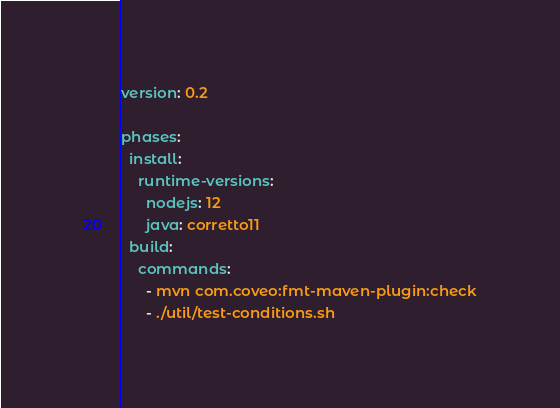<code> <loc_0><loc_0><loc_500><loc_500><_YAML_>version: 0.2

phases:
  install:
    runtime-versions:
      nodejs: 12
      java: corretto11
  build:
    commands:
      - mvn com.coveo:fmt-maven-plugin:check
      - ./util/test-conditions.sh
</code> 